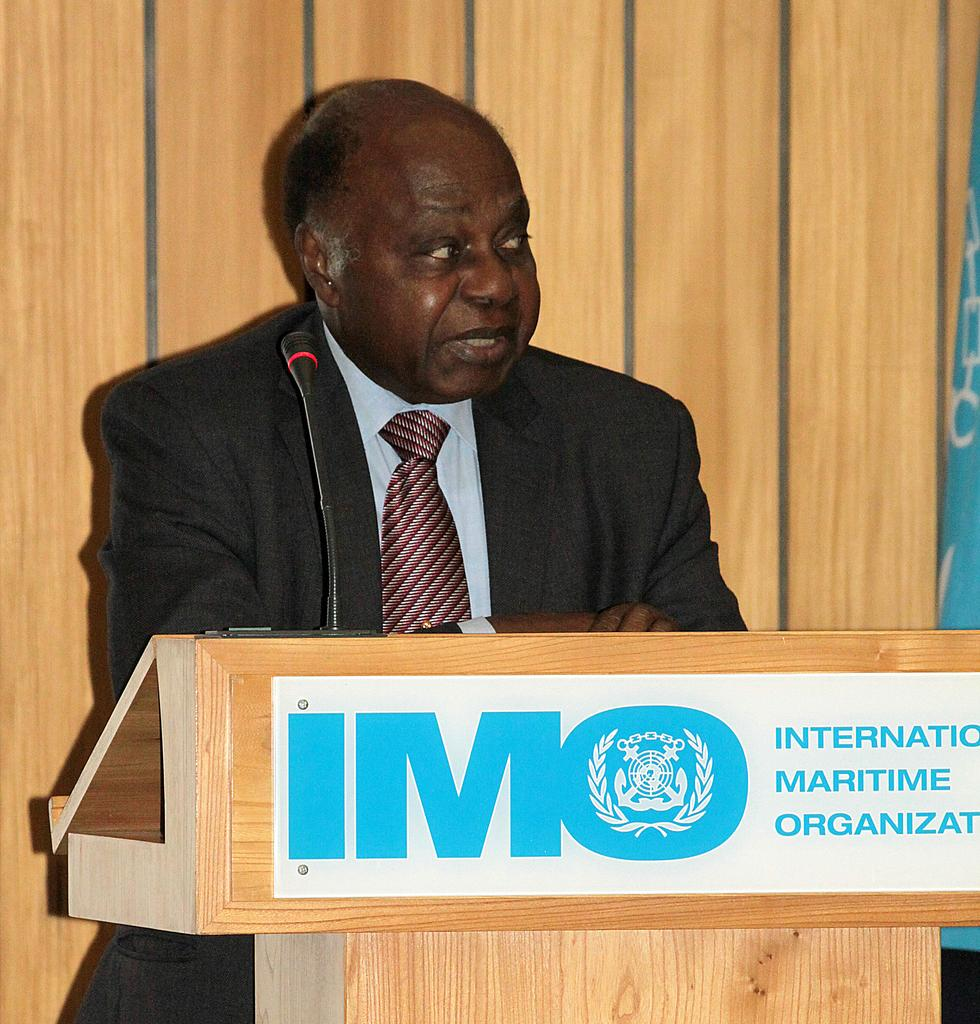Who is the main subject in the image? There is a man in the image. What is the man doing in the image? The man is speaking near a podium. What type of clothing is the man wearing? The man is wearing a tie, a shirt, and a coat. What is present in the background of the image? There is a white board in the image. How does the man fall off the podium in the image? The man does not fall off the podium in the image; he is standing near it while speaking. What type of cream is being used by the man in the image? There is no cream present in the image; the man is wearing a tie, a shirt, and a coat while speaking near a podium. 